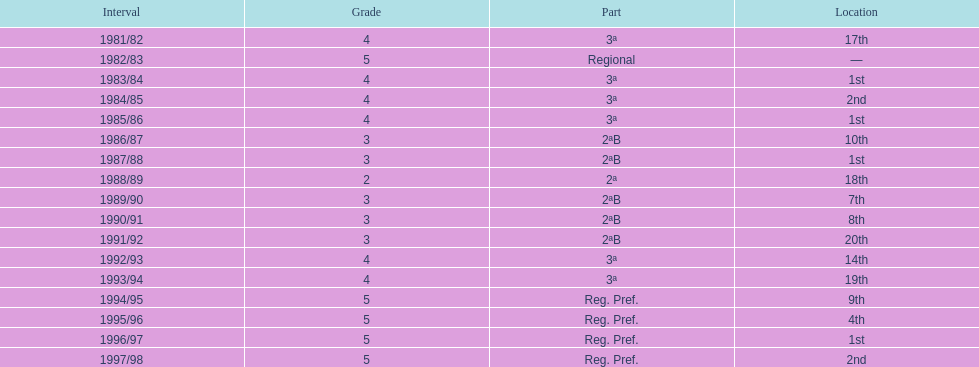What is the count of instances where second place was secured? 2. 